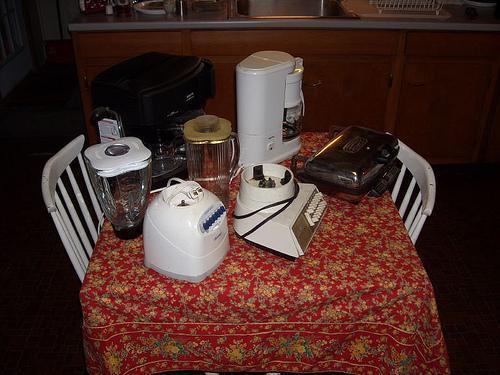How many blenders are in the picture?
Give a very brief answer. 2. How many tables are in the photograph?
Give a very brief answer. 1. How many chairs are visible?
Give a very brief answer. 2. How many chairs are in the picture?
Give a very brief answer. 2. How many girls do you see?
Give a very brief answer. 0. 